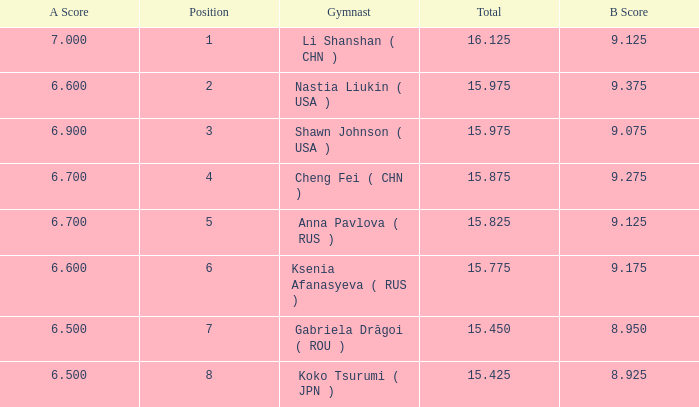What the B Score when the total is 16.125 and the position is less than 7? 9.125. 